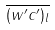<formula> <loc_0><loc_0><loc_500><loc_500>\overline { ( w ^ { \prime } c ^ { \prime } ) _ { l } }</formula> 